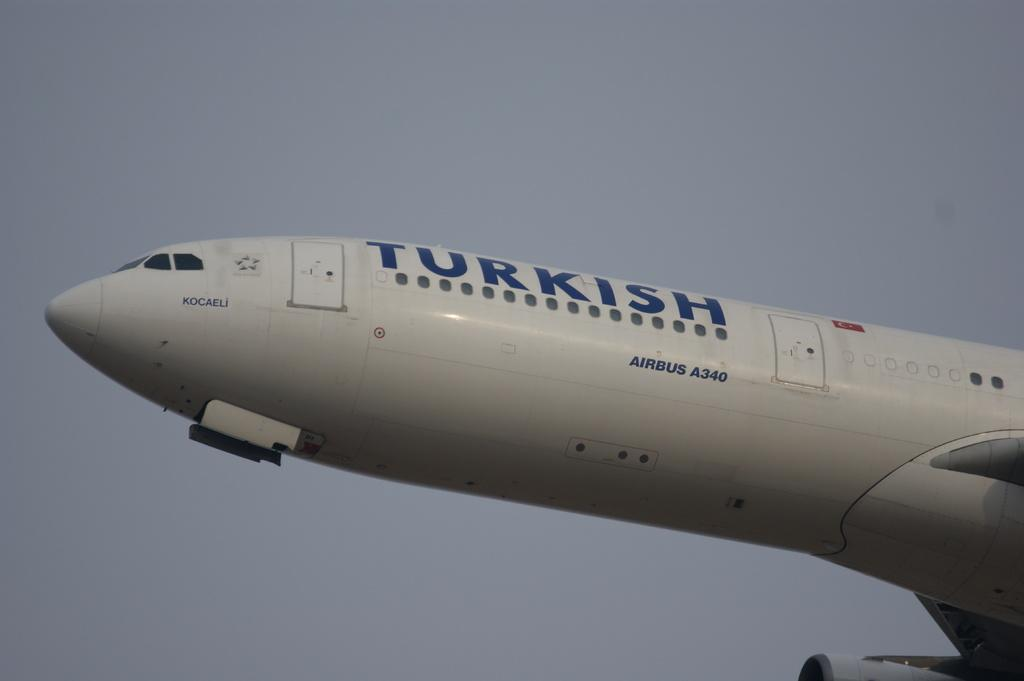Provide a one-sentence caption for the provided image. A white plane in the air with Turkish written on it. 